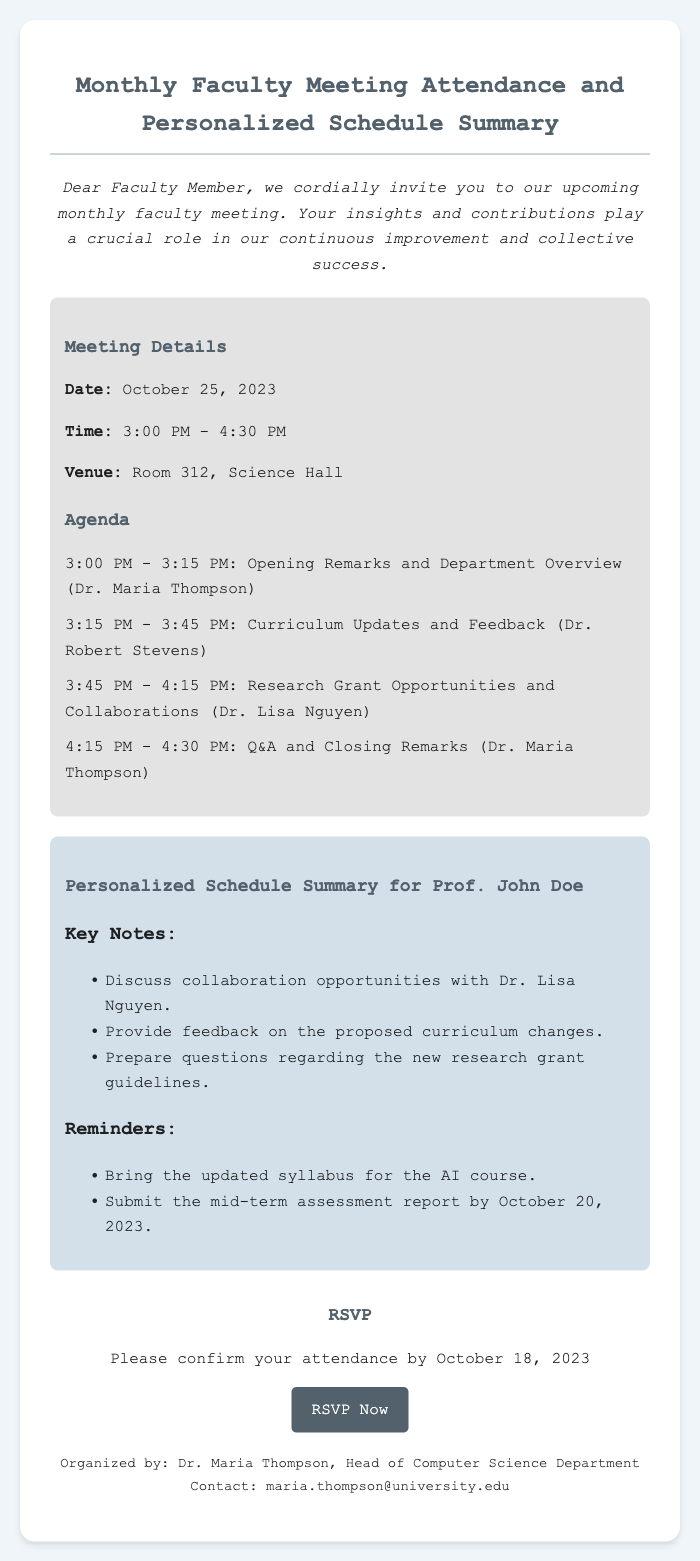What is the date of the meeting? The date of the meeting is specifically mentioned in the document as October 25, 2023.
Answer: October 25, 2023 What time does the meeting start? The meeting's start time is highlighted in the document, specifically noted as 3:00 PM.
Answer: 3:00 PM Who will lead the opening remarks? The document indicates that Dr. Maria Thompson will lead the opening remarks during the meeting.
Answer: Dr. Maria Thompson What is one of Prof. John Doe's key notes? A key note for Prof. John Doe is listed in the personalized schedule, mentioning collaboration with Dr. Lisa Nguyen.
Answer: Discuss collaboration opportunities with Dr. Lisa Nguyen By what date should attendance be confirmed? The document clearly states that attendance should be confirmed by October 18, 2023.
Answer: October 18, 2023 How long is the meeting scheduled to last? The total duration of the meeting is calculated from the start time to the end time, which is from 3:00 PM to 4:30 PM, making it 1 hour and 30 minutes.
Answer: 1 hour and 30 minutes What venue will the meeting be held in? The document specifies that the meeting will take place in Room 312, Science Hall.
Answer: Room 312, Science Hall What should Prof. John Doe bring to the meeting? One of the reminders for Prof. John Doe mentions bringing the updated syllabus for the AI course.
Answer: Updated syllabus for the AI course Who is the contact person for the meeting? The contact person for the meeting is detailed in the document, specifically named as Dr. Maria Thompson.
Answer: Dr. Maria Thompson 